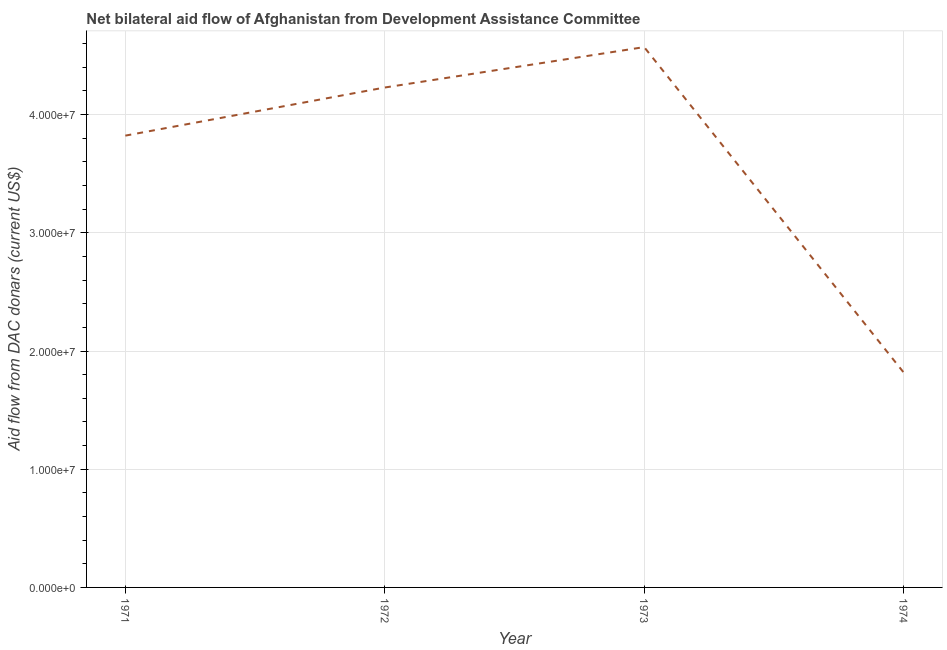What is the net bilateral aid flows from dac donors in 1971?
Your answer should be very brief. 3.82e+07. Across all years, what is the maximum net bilateral aid flows from dac donors?
Your answer should be very brief. 4.57e+07. Across all years, what is the minimum net bilateral aid flows from dac donors?
Your answer should be very brief. 1.82e+07. In which year was the net bilateral aid flows from dac donors maximum?
Offer a very short reply. 1973. In which year was the net bilateral aid flows from dac donors minimum?
Your answer should be very brief. 1974. What is the sum of the net bilateral aid flows from dac donors?
Your answer should be compact. 1.44e+08. What is the difference between the net bilateral aid flows from dac donors in 1972 and 1973?
Offer a very short reply. -3.42e+06. What is the average net bilateral aid flows from dac donors per year?
Make the answer very short. 3.61e+07. What is the median net bilateral aid flows from dac donors?
Provide a succinct answer. 4.03e+07. In how many years, is the net bilateral aid flows from dac donors greater than 2000000 US$?
Provide a succinct answer. 4. Do a majority of the years between 1973 and 1972 (inclusive) have net bilateral aid flows from dac donors greater than 38000000 US$?
Your answer should be very brief. No. What is the ratio of the net bilateral aid flows from dac donors in 1973 to that in 1974?
Your response must be concise. 2.51. Is the difference between the net bilateral aid flows from dac donors in 1972 and 1973 greater than the difference between any two years?
Ensure brevity in your answer.  No. What is the difference between the highest and the second highest net bilateral aid flows from dac donors?
Your answer should be compact. 3.42e+06. Is the sum of the net bilateral aid flows from dac donors in 1971 and 1974 greater than the maximum net bilateral aid flows from dac donors across all years?
Make the answer very short. Yes. What is the difference between the highest and the lowest net bilateral aid flows from dac donors?
Provide a short and direct response. 2.75e+07. Does the net bilateral aid flows from dac donors monotonically increase over the years?
Make the answer very short. No. How many years are there in the graph?
Your answer should be very brief. 4. Does the graph contain any zero values?
Provide a short and direct response. No. Does the graph contain grids?
Your response must be concise. Yes. What is the title of the graph?
Your response must be concise. Net bilateral aid flow of Afghanistan from Development Assistance Committee. What is the label or title of the X-axis?
Make the answer very short. Year. What is the label or title of the Y-axis?
Your answer should be compact. Aid flow from DAC donars (current US$). What is the Aid flow from DAC donars (current US$) of 1971?
Provide a short and direct response. 3.82e+07. What is the Aid flow from DAC donars (current US$) of 1972?
Provide a short and direct response. 4.23e+07. What is the Aid flow from DAC donars (current US$) in 1973?
Your answer should be very brief. 4.57e+07. What is the Aid flow from DAC donars (current US$) of 1974?
Make the answer very short. 1.82e+07. What is the difference between the Aid flow from DAC donars (current US$) in 1971 and 1972?
Offer a terse response. -4.07e+06. What is the difference between the Aid flow from DAC donars (current US$) in 1971 and 1973?
Offer a terse response. -7.49e+06. What is the difference between the Aid flow from DAC donars (current US$) in 1971 and 1974?
Keep it short and to the point. 2.00e+07. What is the difference between the Aid flow from DAC donars (current US$) in 1972 and 1973?
Keep it short and to the point. -3.42e+06. What is the difference between the Aid flow from DAC donars (current US$) in 1972 and 1974?
Offer a very short reply. 2.41e+07. What is the difference between the Aid flow from DAC donars (current US$) in 1973 and 1974?
Offer a very short reply. 2.75e+07. What is the ratio of the Aid flow from DAC donars (current US$) in 1971 to that in 1972?
Provide a short and direct response. 0.9. What is the ratio of the Aid flow from DAC donars (current US$) in 1971 to that in 1973?
Offer a terse response. 0.84. What is the ratio of the Aid flow from DAC donars (current US$) in 1971 to that in 1974?
Provide a succinct answer. 2.1. What is the ratio of the Aid flow from DAC donars (current US$) in 1972 to that in 1973?
Your answer should be very brief. 0.93. What is the ratio of the Aid flow from DAC donars (current US$) in 1972 to that in 1974?
Provide a succinct answer. 2.33. What is the ratio of the Aid flow from DAC donars (current US$) in 1973 to that in 1974?
Provide a succinct answer. 2.51. 